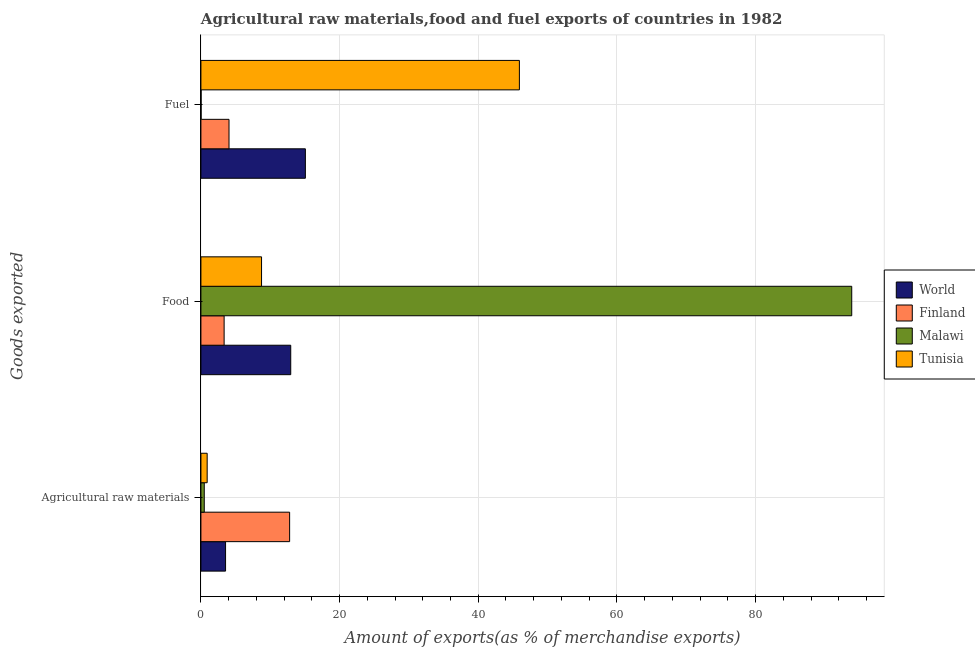How many different coloured bars are there?
Your answer should be compact. 4. How many groups of bars are there?
Offer a terse response. 3. Are the number of bars per tick equal to the number of legend labels?
Offer a terse response. Yes. Are the number of bars on each tick of the Y-axis equal?
Offer a very short reply. Yes. How many bars are there on the 2nd tick from the top?
Ensure brevity in your answer.  4. What is the label of the 2nd group of bars from the top?
Your response must be concise. Food. What is the percentage of raw materials exports in Tunisia?
Your answer should be compact. 0.9. Across all countries, what is the maximum percentage of food exports?
Offer a terse response. 93.87. Across all countries, what is the minimum percentage of raw materials exports?
Make the answer very short. 0.48. In which country was the percentage of food exports maximum?
Make the answer very short. Malawi. In which country was the percentage of raw materials exports minimum?
Provide a short and direct response. Malawi. What is the total percentage of food exports in the graph?
Give a very brief answer. 118.92. What is the difference between the percentage of fuel exports in World and that in Malawi?
Provide a short and direct response. 15.04. What is the difference between the percentage of raw materials exports in World and the percentage of food exports in Tunisia?
Keep it short and to the point. -5.19. What is the average percentage of raw materials exports per country?
Provide a succinct answer. 4.43. What is the difference between the percentage of food exports and percentage of fuel exports in Finland?
Provide a succinct answer. -0.7. In how many countries, is the percentage of raw materials exports greater than 32 %?
Offer a very short reply. 0. What is the ratio of the percentage of fuel exports in Tunisia to that in Finland?
Your answer should be very brief. 11.33. What is the difference between the highest and the second highest percentage of food exports?
Make the answer very short. 80.92. What is the difference between the highest and the lowest percentage of fuel exports?
Make the answer very short. 45.91. In how many countries, is the percentage of fuel exports greater than the average percentage of fuel exports taken over all countries?
Your answer should be very brief. 1. Is the sum of the percentage of raw materials exports in World and Tunisia greater than the maximum percentage of food exports across all countries?
Provide a succinct answer. No. What does the 2nd bar from the top in Agricultural raw materials represents?
Provide a succinct answer. Malawi. What does the 3rd bar from the bottom in Fuel represents?
Offer a very short reply. Malawi. Is it the case that in every country, the sum of the percentage of raw materials exports and percentage of food exports is greater than the percentage of fuel exports?
Your answer should be very brief. No. Are all the bars in the graph horizontal?
Make the answer very short. Yes. What is the difference between two consecutive major ticks on the X-axis?
Make the answer very short. 20. Where does the legend appear in the graph?
Provide a short and direct response. Center right. How are the legend labels stacked?
Give a very brief answer. Vertical. What is the title of the graph?
Give a very brief answer. Agricultural raw materials,food and fuel exports of countries in 1982. What is the label or title of the X-axis?
Keep it short and to the point. Amount of exports(as % of merchandise exports). What is the label or title of the Y-axis?
Keep it short and to the point. Goods exported. What is the Amount of exports(as % of merchandise exports) in World in Agricultural raw materials?
Your response must be concise. 3.55. What is the Amount of exports(as % of merchandise exports) in Finland in Agricultural raw materials?
Your answer should be compact. 12.8. What is the Amount of exports(as % of merchandise exports) of Malawi in Agricultural raw materials?
Your answer should be compact. 0.48. What is the Amount of exports(as % of merchandise exports) of Tunisia in Agricultural raw materials?
Ensure brevity in your answer.  0.9. What is the Amount of exports(as % of merchandise exports) in World in Food?
Your response must be concise. 12.96. What is the Amount of exports(as % of merchandise exports) of Finland in Food?
Your response must be concise. 3.35. What is the Amount of exports(as % of merchandise exports) in Malawi in Food?
Ensure brevity in your answer.  93.87. What is the Amount of exports(as % of merchandise exports) of Tunisia in Food?
Ensure brevity in your answer.  8.75. What is the Amount of exports(as % of merchandise exports) of World in Fuel?
Provide a short and direct response. 15.07. What is the Amount of exports(as % of merchandise exports) of Finland in Fuel?
Ensure brevity in your answer.  4.05. What is the Amount of exports(as % of merchandise exports) of Malawi in Fuel?
Your response must be concise. 0.03. What is the Amount of exports(as % of merchandise exports) in Tunisia in Fuel?
Offer a terse response. 45.94. Across all Goods exported, what is the maximum Amount of exports(as % of merchandise exports) in World?
Ensure brevity in your answer.  15.07. Across all Goods exported, what is the maximum Amount of exports(as % of merchandise exports) of Finland?
Make the answer very short. 12.8. Across all Goods exported, what is the maximum Amount of exports(as % of merchandise exports) in Malawi?
Give a very brief answer. 93.87. Across all Goods exported, what is the maximum Amount of exports(as % of merchandise exports) of Tunisia?
Provide a short and direct response. 45.94. Across all Goods exported, what is the minimum Amount of exports(as % of merchandise exports) of World?
Your response must be concise. 3.55. Across all Goods exported, what is the minimum Amount of exports(as % of merchandise exports) in Finland?
Provide a succinct answer. 3.35. Across all Goods exported, what is the minimum Amount of exports(as % of merchandise exports) in Malawi?
Make the answer very short. 0.03. Across all Goods exported, what is the minimum Amount of exports(as % of merchandise exports) of Tunisia?
Your answer should be compact. 0.9. What is the total Amount of exports(as % of merchandise exports) of World in the graph?
Offer a very short reply. 31.58. What is the total Amount of exports(as % of merchandise exports) of Finland in the graph?
Ensure brevity in your answer.  20.2. What is the total Amount of exports(as % of merchandise exports) in Malawi in the graph?
Give a very brief answer. 94.38. What is the total Amount of exports(as % of merchandise exports) in Tunisia in the graph?
Provide a short and direct response. 55.58. What is the difference between the Amount of exports(as % of merchandise exports) of World in Agricultural raw materials and that in Food?
Your response must be concise. -9.4. What is the difference between the Amount of exports(as % of merchandise exports) in Finland in Agricultural raw materials and that in Food?
Your answer should be very brief. 9.45. What is the difference between the Amount of exports(as % of merchandise exports) of Malawi in Agricultural raw materials and that in Food?
Make the answer very short. -93.39. What is the difference between the Amount of exports(as % of merchandise exports) of Tunisia in Agricultural raw materials and that in Food?
Your answer should be very brief. -7.84. What is the difference between the Amount of exports(as % of merchandise exports) of World in Agricultural raw materials and that in Fuel?
Your answer should be compact. -11.51. What is the difference between the Amount of exports(as % of merchandise exports) in Finland in Agricultural raw materials and that in Fuel?
Give a very brief answer. 8.74. What is the difference between the Amount of exports(as % of merchandise exports) of Malawi in Agricultural raw materials and that in Fuel?
Provide a short and direct response. 0.46. What is the difference between the Amount of exports(as % of merchandise exports) in Tunisia in Agricultural raw materials and that in Fuel?
Provide a short and direct response. -45.03. What is the difference between the Amount of exports(as % of merchandise exports) in World in Food and that in Fuel?
Offer a very short reply. -2.11. What is the difference between the Amount of exports(as % of merchandise exports) of Finland in Food and that in Fuel?
Provide a short and direct response. -0.7. What is the difference between the Amount of exports(as % of merchandise exports) of Malawi in Food and that in Fuel?
Provide a short and direct response. 93.85. What is the difference between the Amount of exports(as % of merchandise exports) of Tunisia in Food and that in Fuel?
Ensure brevity in your answer.  -37.19. What is the difference between the Amount of exports(as % of merchandise exports) in World in Agricultural raw materials and the Amount of exports(as % of merchandise exports) in Finland in Food?
Your answer should be compact. 0.21. What is the difference between the Amount of exports(as % of merchandise exports) of World in Agricultural raw materials and the Amount of exports(as % of merchandise exports) of Malawi in Food?
Your answer should be compact. -90.32. What is the difference between the Amount of exports(as % of merchandise exports) in World in Agricultural raw materials and the Amount of exports(as % of merchandise exports) in Tunisia in Food?
Your answer should be very brief. -5.19. What is the difference between the Amount of exports(as % of merchandise exports) of Finland in Agricultural raw materials and the Amount of exports(as % of merchandise exports) of Malawi in Food?
Offer a very short reply. -81.08. What is the difference between the Amount of exports(as % of merchandise exports) of Finland in Agricultural raw materials and the Amount of exports(as % of merchandise exports) of Tunisia in Food?
Keep it short and to the point. 4.05. What is the difference between the Amount of exports(as % of merchandise exports) of Malawi in Agricultural raw materials and the Amount of exports(as % of merchandise exports) of Tunisia in Food?
Provide a succinct answer. -8.26. What is the difference between the Amount of exports(as % of merchandise exports) of World in Agricultural raw materials and the Amount of exports(as % of merchandise exports) of Finland in Fuel?
Keep it short and to the point. -0.5. What is the difference between the Amount of exports(as % of merchandise exports) in World in Agricultural raw materials and the Amount of exports(as % of merchandise exports) in Malawi in Fuel?
Provide a succinct answer. 3.53. What is the difference between the Amount of exports(as % of merchandise exports) of World in Agricultural raw materials and the Amount of exports(as % of merchandise exports) of Tunisia in Fuel?
Offer a terse response. -42.38. What is the difference between the Amount of exports(as % of merchandise exports) of Finland in Agricultural raw materials and the Amount of exports(as % of merchandise exports) of Malawi in Fuel?
Your answer should be very brief. 12.77. What is the difference between the Amount of exports(as % of merchandise exports) in Finland in Agricultural raw materials and the Amount of exports(as % of merchandise exports) in Tunisia in Fuel?
Make the answer very short. -33.14. What is the difference between the Amount of exports(as % of merchandise exports) of Malawi in Agricultural raw materials and the Amount of exports(as % of merchandise exports) of Tunisia in Fuel?
Give a very brief answer. -45.45. What is the difference between the Amount of exports(as % of merchandise exports) in World in Food and the Amount of exports(as % of merchandise exports) in Finland in Fuel?
Offer a very short reply. 8.9. What is the difference between the Amount of exports(as % of merchandise exports) of World in Food and the Amount of exports(as % of merchandise exports) of Malawi in Fuel?
Offer a terse response. 12.93. What is the difference between the Amount of exports(as % of merchandise exports) in World in Food and the Amount of exports(as % of merchandise exports) in Tunisia in Fuel?
Your answer should be compact. -32.98. What is the difference between the Amount of exports(as % of merchandise exports) of Finland in Food and the Amount of exports(as % of merchandise exports) of Malawi in Fuel?
Make the answer very short. 3.32. What is the difference between the Amount of exports(as % of merchandise exports) in Finland in Food and the Amount of exports(as % of merchandise exports) in Tunisia in Fuel?
Your answer should be very brief. -42.59. What is the difference between the Amount of exports(as % of merchandise exports) of Malawi in Food and the Amount of exports(as % of merchandise exports) of Tunisia in Fuel?
Keep it short and to the point. 47.94. What is the average Amount of exports(as % of merchandise exports) in World per Goods exported?
Offer a terse response. 10.53. What is the average Amount of exports(as % of merchandise exports) of Finland per Goods exported?
Give a very brief answer. 6.73. What is the average Amount of exports(as % of merchandise exports) of Malawi per Goods exported?
Your response must be concise. 31.46. What is the average Amount of exports(as % of merchandise exports) of Tunisia per Goods exported?
Provide a succinct answer. 18.53. What is the difference between the Amount of exports(as % of merchandise exports) of World and Amount of exports(as % of merchandise exports) of Finland in Agricultural raw materials?
Provide a short and direct response. -9.24. What is the difference between the Amount of exports(as % of merchandise exports) of World and Amount of exports(as % of merchandise exports) of Malawi in Agricultural raw materials?
Offer a terse response. 3.07. What is the difference between the Amount of exports(as % of merchandise exports) in World and Amount of exports(as % of merchandise exports) in Tunisia in Agricultural raw materials?
Your answer should be very brief. 2.65. What is the difference between the Amount of exports(as % of merchandise exports) in Finland and Amount of exports(as % of merchandise exports) in Malawi in Agricultural raw materials?
Offer a terse response. 12.31. What is the difference between the Amount of exports(as % of merchandise exports) of Finland and Amount of exports(as % of merchandise exports) of Tunisia in Agricultural raw materials?
Your answer should be very brief. 11.89. What is the difference between the Amount of exports(as % of merchandise exports) in Malawi and Amount of exports(as % of merchandise exports) in Tunisia in Agricultural raw materials?
Keep it short and to the point. -0.42. What is the difference between the Amount of exports(as % of merchandise exports) in World and Amount of exports(as % of merchandise exports) in Finland in Food?
Keep it short and to the point. 9.61. What is the difference between the Amount of exports(as % of merchandise exports) of World and Amount of exports(as % of merchandise exports) of Malawi in Food?
Offer a terse response. -80.92. What is the difference between the Amount of exports(as % of merchandise exports) in World and Amount of exports(as % of merchandise exports) in Tunisia in Food?
Ensure brevity in your answer.  4.21. What is the difference between the Amount of exports(as % of merchandise exports) in Finland and Amount of exports(as % of merchandise exports) in Malawi in Food?
Ensure brevity in your answer.  -90.53. What is the difference between the Amount of exports(as % of merchandise exports) in Finland and Amount of exports(as % of merchandise exports) in Tunisia in Food?
Your answer should be compact. -5.4. What is the difference between the Amount of exports(as % of merchandise exports) of Malawi and Amount of exports(as % of merchandise exports) of Tunisia in Food?
Ensure brevity in your answer.  85.13. What is the difference between the Amount of exports(as % of merchandise exports) of World and Amount of exports(as % of merchandise exports) of Finland in Fuel?
Make the answer very short. 11.01. What is the difference between the Amount of exports(as % of merchandise exports) of World and Amount of exports(as % of merchandise exports) of Malawi in Fuel?
Offer a terse response. 15.04. What is the difference between the Amount of exports(as % of merchandise exports) of World and Amount of exports(as % of merchandise exports) of Tunisia in Fuel?
Give a very brief answer. -30.87. What is the difference between the Amount of exports(as % of merchandise exports) of Finland and Amount of exports(as % of merchandise exports) of Malawi in Fuel?
Make the answer very short. 4.03. What is the difference between the Amount of exports(as % of merchandise exports) of Finland and Amount of exports(as % of merchandise exports) of Tunisia in Fuel?
Make the answer very short. -41.88. What is the difference between the Amount of exports(as % of merchandise exports) in Malawi and Amount of exports(as % of merchandise exports) in Tunisia in Fuel?
Keep it short and to the point. -45.91. What is the ratio of the Amount of exports(as % of merchandise exports) of World in Agricultural raw materials to that in Food?
Your response must be concise. 0.27. What is the ratio of the Amount of exports(as % of merchandise exports) of Finland in Agricultural raw materials to that in Food?
Your response must be concise. 3.82. What is the ratio of the Amount of exports(as % of merchandise exports) of Malawi in Agricultural raw materials to that in Food?
Your response must be concise. 0.01. What is the ratio of the Amount of exports(as % of merchandise exports) of Tunisia in Agricultural raw materials to that in Food?
Give a very brief answer. 0.1. What is the ratio of the Amount of exports(as % of merchandise exports) in World in Agricultural raw materials to that in Fuel?
Make the answer very short. 0.24. What is the ratio of the Amount of exports(as % of merchandise exports) in Finland in Agricultural raw materials to that in Fuel?
Offer a very short reply. 3.16. What is the ratio of the Amount of exports(as % of merchandise exports) of Malawi in Agricultural raw materials to that in Fuel?
Provide a short and direct response. 18.79. What is the ratio of the Amount of exports(as % of merchandise exports) in Tunisia in Agricultural raw materials to that in Fuel?
Provide a short and direct response. 0.02. What is the ratio of the Amount of exports(as % of merchandise exports) in World in Food to that in Fuel?
Give a very brief answer. 0.86. What is the ratio of the Amount of exports(as % of merchandise exports) in Finland in Food to that in Fuel?
Your answer should be compact. 0.83. What is the ratio of the Amount of exports(as % of merchandise exports) in Malawi in Food to that in Fuel?
Provide a short and direct response. 3656.54. What is the ratio of the Amount of exports(as % of merchandise exports) in Tunisia in Food to that in Fuel?
Provide a short and direct response. 0.19. What is the difference between the highest and the second highest Amount of exports(as % of merchandise exports) of World?
Your response must be concise. 2.11. What is the difference between the highest and the second highest Amount of exports(as % of merchandise exports) of Finland?
Provide a short and direct response. 8.74. What is the difference between the highest and the second highest Amount of exports(as % of merchandise exports) of Malawi?
Give a very brief answer. 93.39. What is the difference between the highest and the second highest Amount of exports(as % of merchandise exports) of Tunisia?
Your answer should be very brief. 37.19. What is the difference between the highest and the lowest Amount of exports(as % of merchandise exports) of World?
Your answer should be very brief. 11.51. What is the difference between the highest and the lowest Amount of exports(as % of merchandise exports) of Finland?
Keep it short and to the point. 9.45. What is the difference between the highest and the lowest Amount of exports(as % of merchandise exports) in Malawi?
Your answer should be compact. 93.85. What is the difference between the highest and the lowest Amount of exports(as % of merchandise exports) in Tunisia?
Keep it short and to the point. 45.03. 